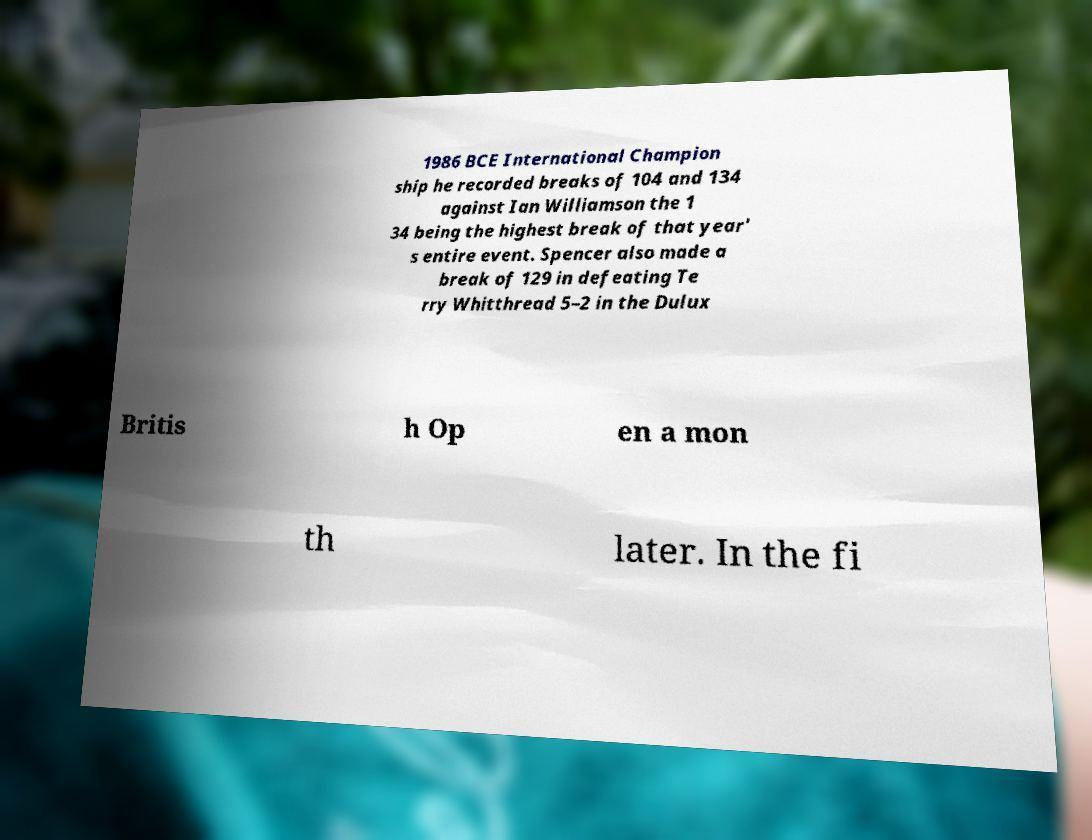There's text embedded in this image that I need extracted. Can you transcribe it verbatim? 1986 BCE International Champion ship he recorded breaks of 104 and 134 against Ian Williamson the 1 34 being the highest break of that year' s entire event. Spencer also made a break of 129 in defeating Te rry Whitthread 5–2 in the Dulux Britis h Op en a mon th later. In the fi 